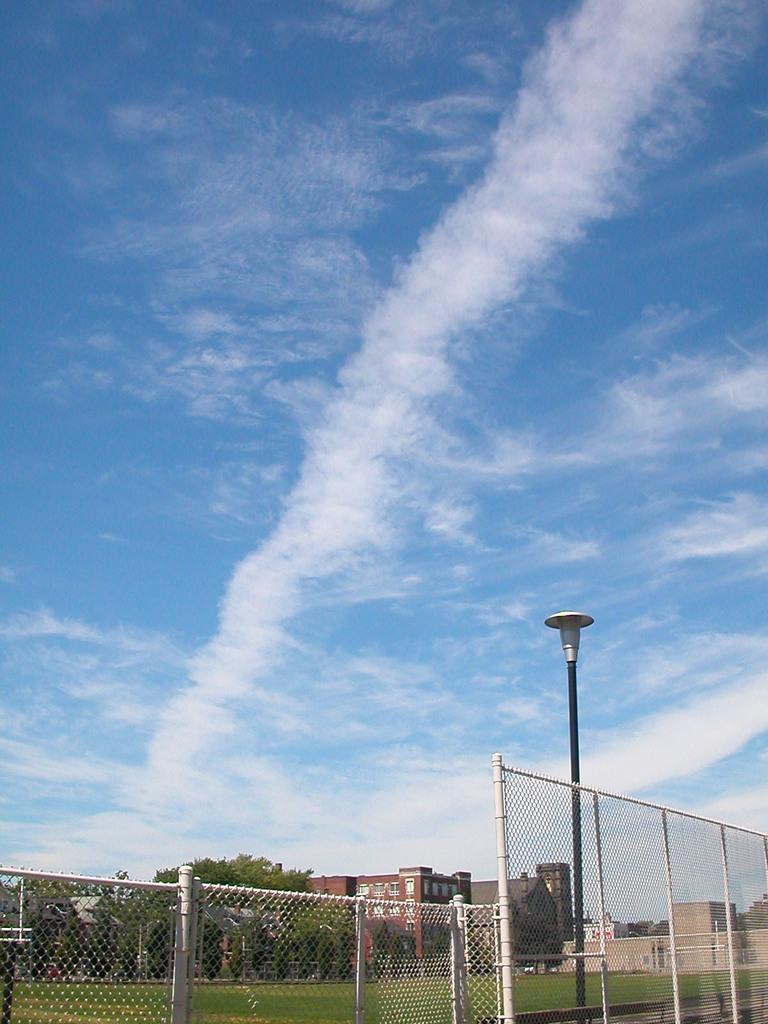Could you give a brief overview of what you see in this image? This is the picture of a place where we have a fencing on the grass floor and to the side there is a pole which has a light and some houses and trees around. 